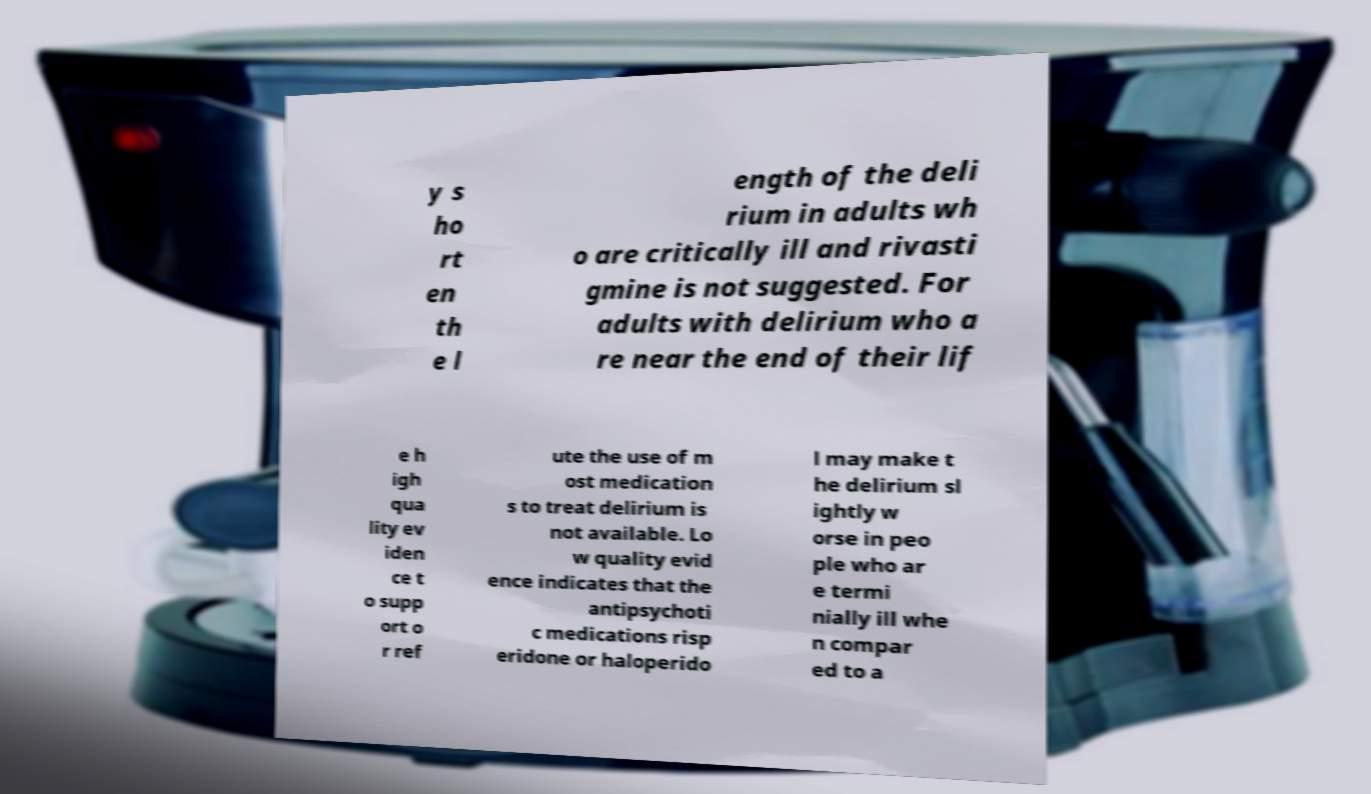Can you read and provide the text displayed in the image?This photo seems to have some interesting text. Can you extract and type it out for me? y s ho rt en th e l ength of the deli rium in adults wh o are critically ill and rivasti gmine is not suggested. For adults with delirium who a re near the end of their lif e h igh qua lity ev iden ce t o supp ort o r ref ute the use of m ost medication s to treat delirium is not available. Lo w quality evid ence indicates that the antipsychoti c medications risp eridone or haloperido l may make t he delirium sl ightly w orse in peo ple who ar e termi nially ill whe n compar ed to a 